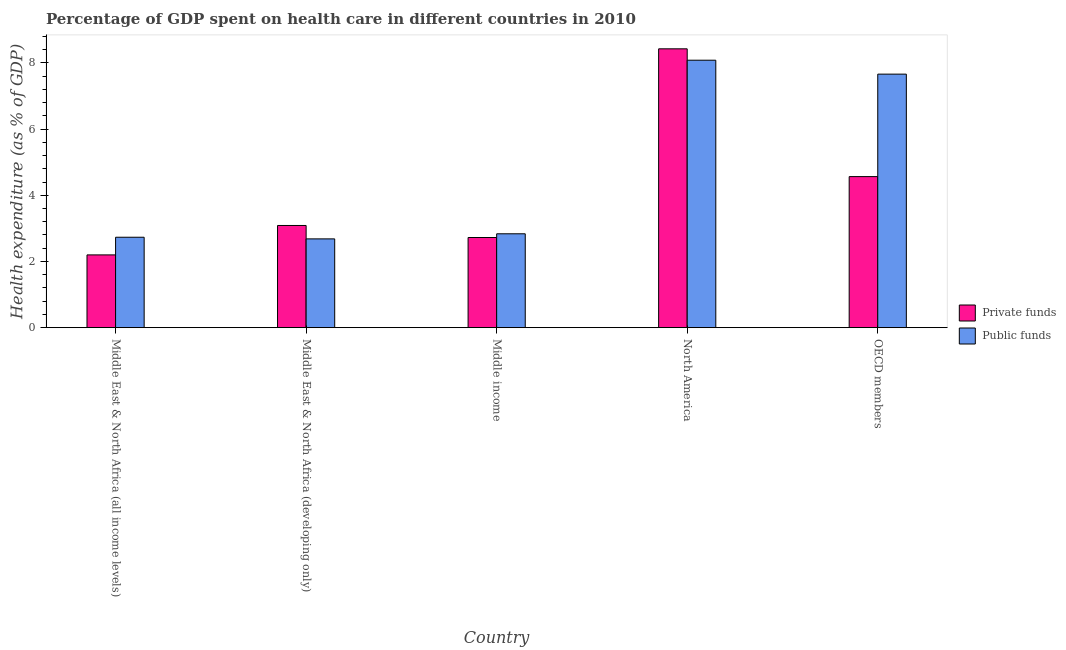Are the number of bars per tick equal to the number of legend labels?
Keep it short and to the point. Yes. Are the number of bars on each tick of the X-axis equal?
Keep it short and to the point. Yes. How many bars are there on the 2nd tick from the left?
Provide a short and direct response. 2. What is the label of the 5th group of bars from the left?
Ensure brevity in your answer.  OECD members. What is the amount of public funds spent in healthcare in North America?
Make the answer very short. 8.08. Across all countries, what is the maximum amount of public funds spent in healthcare?
Your answer should be very brief. 8.08. Across all countries, what is the minimum amount of public funds spent in healthcare?
Offer a terse response. 2.68. In which country was the amount of private funds spent in healthcare maximum?
Offer a very short reply. North America. In which country was the amount of public funds spent in healthcare minimum?
Your answer should be very brief. Middle East & North Africa (developing only). What is the total amount of public funds spent in healthcare in the graph?
Give a very brief answer. 23.99. What is the difference between the amount of private funds spent in healthcare in Middle East & North Africa (developing only) and that in OECD members?
Provide a succinct answer. -1.48. What is the difference between the amount of private funds spent in healthcare in OECD members and the amount of public funds spent in healthcare in Middle income?
Provide a short and direct response. 1.73. What is the average amount of public funds spent in healthcare per country?
Make the answer very short. 4.8. What is the difference between the amount of public funds spent in healthcare and amount of private funds spent in healthcare in Middle East & North Africa (all income levels)?
Make the answer very short. 0.53. In how many countries, is the amount of public funds spent in healthcare greater than 3.2 %?
Offer a terse response. 2. What is the ratio of the amount of public funds spent in healthcare in Middle East & North Africa (all income levels) to that in Middle income?
Keep it short and to the point. 0.96. What is the difference between the highest and the second highest amount of public funds spent in healthcare?
Provide a succinct answer. 0.42. What is the difference between the highest and the lowest amount of public funds spent in healthcare?
Ensure brevity in your answer.  5.4. In how many countries, is the amount of public funds spent in healthcare greater than the average amount of public funds spent in healthcare taken over all countries?
Your answer should be compact. 2. What does the 2nd bar from the left in Middle income represents?
Offer a terse response. Public funds. What does the 2nd bar from the right in Middle income represents?
Offer a very short reply. Private funds. How many bars are there?
Offer a very short reply. 10. How many countries are there in the graph?
Offer a very short reply. 5. What is the difference between two consecutive major ticks on the Y-axis?
Keep it short and to the point. 2. Does the graph contain any zero values?
Your answer should be very brief. No. How many legend labels are there?
Ensure brevity in your answer.  2. What is the title of the graph?
Offer a very short reply. Percentage of GDP spent on health care in different countries in 2010. Does "Travel Items" appear as one of the legend labels in the graph?
Offer a very short reply. No. What is the label or title of the X-axis?
Ensure brevity in your answer.  Country. What is the label or title of the Y-axis?
Make the answer very short. Health expenditure (as % of GDP). What is the Health expenditure (as % of GDP) in Private funds in Middle East & North Africa (all income levels)?
Make the answer very short. 2.2. What is the Health expenditure (as % of GDP) in Public funds in Middle East & North Africa (all income levels)?
Provide a short and direct response. 2.73. What is the Health expenditure (as % of GDP) in Private funds in Middle East & North Africa (developing only)?
Give a very brief answer. 3.09. What is the Health expenditure (as % of GDP) in Public funds in Middle East & North Africa (developing only)?
Provide a succinct answer. 2.68. What is the Health expenditure (as % of GDP) of Private funds in Middle income?
Your answer should be very brief. 2.72. What is the Health expenditure (as % of GDP) of Public funds in Middle income?
Ensure brevity in your answer.  2.84. What is the Health expenditure (as % of GDP) of Private funds in North America?
Offer a very short reply. 8.42. What is the Health expenditure (as % of GDP) in Public funds in North America?
Provide a short and direct response. 8.08. What is the Health expenditure (as % of GDP) in Private funds in OECD members?
Provide a succinct answer. 4.56. What is the Health expenditure (as % of GDP) of Public funds in OECD members?
Make the answer very short. 7.66. Across all countries, what is the maximum Health expenditure (as % of GDP) of Private funds?
Ensure brevity in your answer.  8.42. Across all countries, what is the maximum Health expenditure (as % of GDP) in Public funds?
Give a very brief answer. 8.08. Across all countries, what is the minimum Health expenditure (as % of GDP) of Private funds?
Provide a short and direct response. 2.2. Across all countries, what is the minimum Health expenditure (as % of GDP) in Public funds?
Make the answer very short. 2.68. What is the total Health expenditure (as % of GDP) in Private funds in the graph?
Make the answer very short. 21. What is the total Health expenditure (as % of GDP) of Public funds in the graph?
Your answer should be very brief. 23.99. What is the difference between the Health expenditure (as % of GDP) in Private funds in Middle East & North Africa (all income levels) and that in Middle East & North Africa (developing only)?
Keep it short and to the point. -0.89. What is the difference between the Health expenditure (as % of GDP) in Public funds in Middle East & North Africa (all income levels) and that in Middle East & North Africa (developing only)?
Your answer should be very brief. 0.05. What is the difference between the Health expenditure (as % of GDP) in Private funds in Middle East & North Africa (all income levels) and that in Middle income?
Your answer should be compact. -0.53. What is the difference between the Health expenditure (as % of GDP) of Public funds in Middle East & North Africa (all income levels) and that in Middle income?
Give a very brief answer. -0.1. What is the difference between the Health expenditure (as % of GDP) in Private funds in Middle East & North Africa (all income levels) and that in North America?
Your response must be concise. -6.23. What is the difference between the Health expenditure (as % of GDP) in Public funds in Middle East & North Africa (all income levels) and that in North America?
Provide a short and direct response. -5.35. What is the difference between the Health expenditure (as % of GDP) of Private funds in Middle East & North Africa (all income levels) and that in OECD members?
Provide a short and direct response. -2.37. What is the difference between the Health expenditure (as % of GDP) of Public funds in Middle East & North Africa (all income levels) and that in OECD members?
Make the answer very short. -4.93. What is the difference between the Health expenditure (as % of GDP) in Private funds in Middle East & North Africa (developing only) and that in Middle income?
Ensure brevity in your answer.  0.36. What is the difference between the Health expenditure (as % of GDP) in Public funds in Middle East & North Africa (developing only) and that in Middle income?
Make the answer very short. -0.15. What is the difference between the Health expenditure (as % of GDP) in Private funds in Middle East & North Africa (developing only) and that in North America?
Keep it short and to the point. -5.34. What is the difference between the Health expenditure (as % of GDP) of Public funds in Middle East & North Africa (developing only) and that in North America?
Keep it short and to the point. -5.4. What is the difference between the Health expenditure (as % of GDP) of Private funds in Middle East & North Africa (developing only) and that in OECD members?
Offer a terse response. -1.48. What is the difference between the Health expenditure (as % of GDP) of Public funds in Middle East & North Africa (developing only) and that in OECD members?
Offer a terse response. -4.98. What is the difference between the Health expenditure (as % of GDP) in Private funds in Middle income and that in North America?
Offer a very short reply. -5.7. What is the difference between the Health expenditure (as % of GDP) of Public funds in Middle income and that in North America?
Ensure brevity in your answer.  -5.24. What is the difference between the Health expenditure (as % of GDP) in Private funds in Middle income and that in OECD members?
Provide a short and direct response. -1.84. What is the difference between the Health expenditure (as % of GDP) in Public funds in Middle income and that in OECD members?
Your response must be concise. -4.82. What is the difference between the Health expenditure (as % of GDP) of Private funds in North America and that in OECD members?
Your response must be concise. 3.86. What is the difference between the Health expenditure (as % of GDP) of Public funds in North America and that in OECD members?
Give a very brief answer. 0.42. What is the difference between the Health expenditure (as % of GDP) in Private funds in Middle East & North Africa (all income levels) and the Health expenditure (as % of GDP) in Public funds in Middle East & North Africa (developing only)?
Ensure brevity in your answer.  -0.48. What is the difference between the Health expenditure (as % of GDP) of Private funds in Middle East & North Africa (all income levels) and the Health expenditure (as % of GDP) of Public funds in Middle income?
Your answer should be compact. -0.64. What is the difference between the Health expenditure (as % of GDP) in Private funds in Middle East & North Africa (all income levels) and the Health expenditure (as % of GDP) in Public funds in North America?
Provide a short and direct response. -5.88. What is the difference between the Health expenditure (as % of GDP) of Private funds in Middle East & North Africa (all income levels) and the Health expenditure (as % of GDP) of Public funds in OECD members?
Your answer should be compact. -5.46. What is the difference between the Health expenditure (as % of GDP) of Private funds in Middle East & North Africa (developing only) and the Health expenditure (as % of GDP) of Public funds in Middle income?
Keep it short and to the point. 0.25. What is the difference between the Health expenditure (as % of GDP) of Private funds in Middle East & North Africa (developing only) and the Health expenditure (as % of GDP) of Public funds in North America?
Your answer should be very brief. -4.99. What is the difference between the Health expenditure (as % of GDP) of Private funds in Middle East & North Africa (developing only) and the Health expenditure (as % of GDP) of Public funds in OECD members?
Make the answer very short. -4.57. What is the difference between the Health expenditure (as % of GDP) of Private funds in Middle income and the Health expenditure (as % of GDP) of Public funds in North America?
Your answer should be very brief. -5.36. What is the difference between the Health expenditure (as % of GDP) in Private funds in Middle income and the Health expenditure (as % of GDP) in Public funds in OECD members?
Offer a very short reply. -4.94. What is the difference between the Health expenditure (as % of GDP) of Private funds in North America and the Health expenditure (as % of GDP) of Public funds in OECD members?
Provide a short and direct response. 0.76. What is the average Health expenditure (as % of GDP) of Private funds per country?
Give a very brief answer. 4.2. What is the average Health expenditure (as % of GDP) in Public funds per country?
Ensure brevity in your answer.  4.8. What is the difference between the Health expenditure (as % of GDP) of Private funds and Health expenditure (as % of GDP) of Public funds in Middle East & North Africa (all income levels)?
Your response must be concise. -0.53. What is the difference between the Health expenditure (as % of GDP) in Private funds and Health expenditure (as % of GDP) in Public funds in Middle East & North Africa (developing only)?
Your answer should be compact. 0.4. What is the difference between the Health expenditure (as % of GDP) of Private funds and Health expenditure (as % of GDP) of Public funds in Middle income?
Offer a very short reply. -0.11. What is the difference between the Health expenditure (as % of GDP) in Private funds and Health expenditure (as % of GDP) in Public funds in North America?
Provide a short and direct response. 0.34. What is the difference between the Health expenditure (as % of GDP) of Private funds and Health expenditure (as % of GDP) of Public funds in OECD members?
Offer a terse response. -3.1. What is the ratio of the Health expenditure (as % of GDP) of Private funds in Middle East & North Africa (all income levels) to that in Middle East & North Africa (developing only)?
Your answer should be very brief. 0.71. What is the ratio of the Health expenditure (as % of GDP) in Public funds in Middle East & North Africa (all income levels) to that in Middle East & North Africa (developing only)?
Your answer should be compact. 1.02. What is the ratio of the Health expenditure (as % of GDP) in Private funds in Middle East & North Africa (all income levels) to that in Middle income?
Offer a very short reply. 0.81. What is the ratio of the Health expenditure (as % of GDP) in Public funds in Middle East & North Africa (all income levels) to that in Middle income?
Your response must be concise. 0.96. What is the ratio of the Health expenditure (as % of GDP) of Private funds in Middle East & North Africa (all income levels) to that in North America?
Offer a very short reply. 0.26. What is the ratio of the Health expenditure (as % of GDP) of Public funds in Middle East & North Africa (all income levels) to that in North America?
Provide a short and direct response. 0.34. What is the ratio of the Health expenditure (as % of GDP) of Private funds in Middle East & North Africa (all income levels) to that in OECD members?
Make the answer very short. 0.48. What is the ratio of the Health expenditure (as % of GDP) of Public funds in Middle East & North Africa (all income levels) to that in OECD members?
Your answer should be very brief. 0.36. What is the ratio of the Health expenditure (as % of GDP) in Private funds in Middle East & North Africa (developing only) to that in Middle income?
Your answer should be very brief. 1.13. What is the ratio of the Health expenditure (as % of GDP) of Public funds in Middle East & North Africa (developing only) to that in Middle income?
Your response must be concise. 0.95. What is the ratio of the Health expenditure (as % of GDP) of Private funds in Middle East & North Africa (developing only) to that in North America?
Your response must be concise. 0.37. What is the ratio of the Health expenditure (as % of GDP) of Public funds in Middle East & North Africa (developing only) to that in North America?
Offer a terse response. 0.33. What is the ratio of the Health expenditure (as % of GDP) in Private funds in Middle East & North Africa (developing only) to that in OECD members?
Give a very brief answer. 0.68. What is the ratio of the Health expenditure (as % of GDP) of Public funds in Middle East & North Africa (developing only) to that in OECD members?
Offer a terse response. 0.35. What is the ratio of the Health expenditure (as % of GDP) in Private funds in Middle income to that in North America?
Your response must be concise. 0.32. What is the ratio of the Health expenditure (as % of GDP) in Public funds in Middle income to that in North America?
Your answer should be compact. 0.35. What is the ratio of the Health expenditure (as % of GDP) in Private funds in Middle income to that in OECD members?
Give a very brief answer. 0.6. What is the ratio of the Health expenditure (as % of GDP) of Public funds in Middle income to that in OECD members?
Ensure brevity in your answer.  0.37. What is the ratio of the Health expenditure (as % of GDP) of Private funds in North America to that in OECD members?
Ensure brevity in your answer.  1.85. What is the ratio of the Health expenditure (as % of GDP) in Public funds in North America to that in OECD members?
Give a very brief answer. 1.05. What is the difference between the highest and the second highest Health expenditure (as % of GDP) in Private funds?
Keep it short and to the point. 3.86. What is the difference between the highest and the second highest Health expenditure (as % of GDP) in Public funds?
Offer a terse response. 0.42. What is the difference between the highest and the lowest Health expenditure (as % of GDP) of Private funds?
Ensure brevity in your answer.  6.23. What is the difference between the highest and the lowest Health expenditure (as % of GDP) in Public funds?
Offer a very short reply. 5.4. 